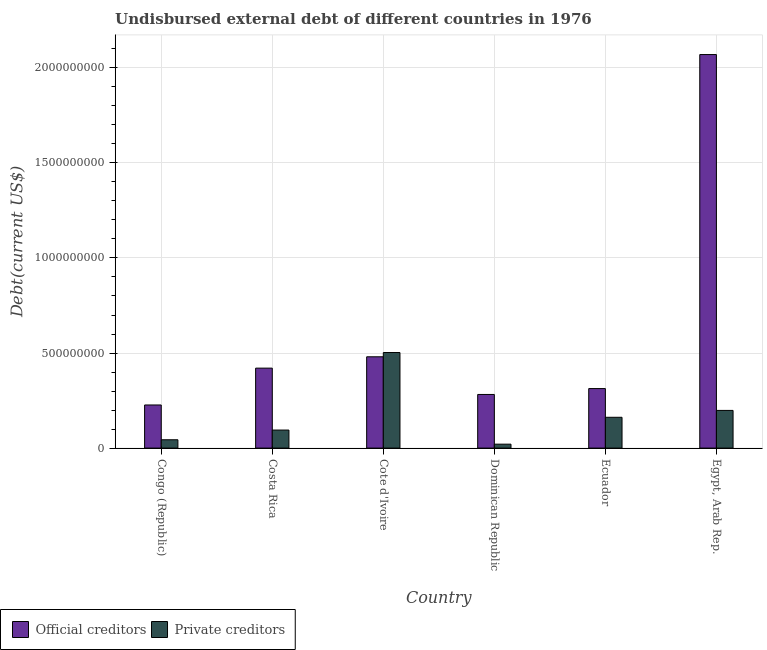How many groups of bars are there?
Your answer should be compact. 6. Are the number of bars per tick equal to the number of legend labels?
Make the answer very short. Yes. What is the label of the 2nd group of bars from the left?
Offer a terse response. Costa Rica. In how many cases, is the number of bars for a given country not equal to the number of legend labels?
Make the answer very short. 0. What is the undisbursed external debt of private creditors in Cote d'Ivoire?
Offer a very short reply. 5.03e+08. Across all countries, what is the maximum undisbursed external debt of private creditors?
Offer a terse response. 5.03e+08. Across all countries, what is the minimum undisbursed external debt of official creditors?
Make the answer very short. 2.27e+08. In which country was the undisbursed external debt of private creditors maximum?
Keep it short and to the point. Cote d'Ivoire. In which country was the undisbursed external debt of private creditors minimum?
Make the answer very short. Dominican Republic. What is the total undisbursed external debt of private creditors in the graph?
Ensure brevity in your answer.  1.02e+09. What is the difference between the undisbursed external debt of official creditors in Congo (Republic) and that in Costa Rica?
Ensure brevity in your answer.  -1.94e+08. What is the difference between the undisbursed external debt of private creditors in Cote d'Ivoire and the undisbursed external debt of official creditors in Dominican Republic?
Make the answer very short. 2.21e+08. What is the average undisbursed external debt of official creditors per country?
Your response must be concise. 6.32e+08. What is the difference between the undisbursed external debt of official creditors and undisbursed external debt of private creditors in Dominican Republic?
Your response must be concise. 2.61e+08. In how many countries, is the undisbursed external debt of official creditors greater than 1100000000 US$?
Give a very brief answer. 1. What is the ratio of the undisbursed external debt of private creditors in Congo (Republic) to that in Dominican Republic?
Keep it short and to the point. 2.12. Is the difference between the undisbursed external debt of private creditors in Ecuador and Egypt, Arab Rep. greater than the difference between the undisbursed external debt of official creditors in Ecuador and Egypt, Arab Rep.?
Ensure brevity in your answer.  Yes. What is the difference between the highest and the second highest undisbursed external debt of private creditors?
Offer a terse response. 3.04e+08. What is the difference between the highest and the lowest undisbursed external debt of private creditors?
Offer a very short reply. 4.82e+08. What does the 1st bar from the left in Cote d'Ivoire represents?
Provide a succinct answer. Official creditors. What does the 1st bar from the right in Costa Rica represents?
Your answer should be compact. Private creditors. How many bars are there?
Your answer should be compact. 12. Are all the bars in the graph horizontal?
Your answer should be compact. No. How many countries are there in the graph?
Your answer should be very brief. 6. What is the difference between two consecutive major ticks on the Y-axis?
Offer a terse response. 5.00e+08. Are the values on the major ticks of Y-axis written in scientific E-notation?
Your answer should be very brief. No. Where does the legend appear in the graph?
Provide a succinct answer. Bottom left. How many legend labels are there?
Keep it short and to the point. 2. How are the legend labels stacked?
Offer a terse response. Horizontal. What is the title of the graph?
Your answer should be very brief. Undisbursed external debt of different countries in 1976. Does "Foreign liabilities" appear as one of the legend labels in the graph?
Your answer should be very brief. No. What is the label or title of the X-axis?
Your answer should be very brief. Country. What is the label or title of the Y-axis?
Keep it short and to the point. Debt(current US$). What is the Debt(current US$) in Official creditors in Congo (Republic)?
Provide a succinct answer. 2.27e+08. What is the Debt(current US$) of Private creditors in Congo (Republic)?
Your answer should be compact. 4.38e+07. What is the Debt(current US$) in Official creditors in Costa Rica?
Make the answer very short. 4.21e+08. What is the Debt(current US$) of Private creditors in Costa Rica?
Your response must be concise. 9.49e+07. What is the Debt(current US$) of Official creditors in Cote d'Ivoire?
Provide a short and direct response. 4.80e+08. What is the Debt(current US$) in Private creditors in Cote d'Ivoire?
Your answer should be compact. 5.03e+08. What is the Debt(current US$) of Official creditors in Dominican Republic?
Offer a terse response. 2.82e+08. What is the Debt(current US$) of Private creditors in Dominican Republic?
Offer a very short reply. 2.07e+07. What is the Debt(current US$) of Official creditors in Ecuador?
Keep it short and to the point. 3.13e+08. What is the Debt(current US$) in Private creditors in Ecuador?
Your answer should be very brief. 1.62e+08. What is the Debt(current US$) in Official creditors in Egypt, Arab Rep.?
Keep it short and to the point. 2.07e+09. What is the Debt(current US$) in Private creditors in Egypt, Arab Rep.?
Make the answer very short. 1.98e+08. Across all countries, what is the maximum Debt(current US$) in Official creditors?
Make the answer very short. 2.07e+09. Across all countries, what is the maximum Debt(current US$) in Private creditors?
Your answer should be very brief. 5.03e+08. Across all countries, what is the minimum Debt(current US$) of Official creditors?
Offer a very short reply. 2.27e+08. Across all countries, what is the minimum Debt(current US$) in Private creditors?
Make the answer very short. 2.07e+07. What is the total Debt(current US$) of Official creditors in the graph?
Your response must be concise. 3.79e+09. What is the total Debt(current US$) in Private creditors in the graph?
Your response must be concise. 1.02e+09. What is the difference between the Debt(current US$) in Official creditors in Congo (Republic) and that in Costa Rica?
Offer a terse response. -1.94e+08. What is the difference between the Debt(current US$) of Private creditors in Congo (Republic) and that in Costa Rica?
Give a very brief answer. -5.11e+07. What is the difference between the Debt(current US$) in Official creditors in Congo (Republic) and that in Cote d'Ivoire?
Provide a succinct answer. -2.53e+08. What is the difference between the Debt(current US$) of Private creditors in Congo (Republic) and that in Cote d'Ivoire?
Your response must be concise. -4.59e+08. What is the difference between the Debt(current US$) in Official creditors in Congo (Republic) and that in Dominican Republic?
Your answer should be very brief. -5.53e+07. What is the difference between the Debt(current US$) of Private creditors in Congo (Republic) and that in Dominican Republic?
Provide a short and direct response. 2.31e+07. What is the difference between the Debt(current US$) in Official creditors in Congo (Republic) and that in Ecuador?
Make the answer very short. -8.63e+07. What is the difference between the Debt(current US$) of Private creditors in Congo (Republic) and that in Ecuador?
Your answer should be compact. -1.18e+08. What is the difference between the Debt(current US$) in Official creditors in Congo (Republic) and that in Egypt, Arab Rep.?
Provide a succinct answer. -1.84e+09. What is the difference between the Debt(current US$) in Private creditors in Congo (Republic) and that in Egypt, Arab Rep.?
Provide a succinct answer. -1.54e+08. What is the difference between the Debt(current US$) of Official creditors in Costa Rica and that in Cote d'Ivoire?
Offer a terse response. -5.97e+07. What is the difference between the Debt(current US$) in Private creditors in Costa Rica and that in Cote d'Ivoire?
Your response must be concise. -4.08e+08. What is the difference between the Debt(current US$) in Official creditors in Costa Rica and that in Dominican Republic?
Your answer should be very brief. 1.38e+08. What is the difference between the Debt(current US$) of Private creditors in Costa Rica and that in Dominican Republic?
Your response must be concise. 7.42e+07. What is the difference between the Debt(current US$) in Official creditors in Costa Rica and that in Ecuador?
Your answer should be compact. 1.07e+08. What is the difference between the Debt(current US$) of Private creditors in Costa Rica and that in Ecuador?
Your response must be concise. -6.72e+07. What is the difference between the Debt(current US$) in Official creditors in Costa Rica and that in Egypt, Arab Rep.?
Keep it short and to the point. -1.65e+09. What is the difference between the Debt(current US$) in Private creditors in Costa Rica and that in Egypt, Arab Rep.?
Offer a very short reply. -1.03e+08. What is the difference between the Debt(current US$) in Official creditors in Cote d'Ivoire and that in Dominican Republic?
Your answer should be very brief. 1.98e+08. What is the difference between the Debt(current US$) of Private creditors in Cote d'Ivoire and that in Dominican Republic?
Provide a succinct answer. 4.82e+08. What is the difference between the Debt(current US$) in Official creditors in Cote d'Ivoire and that in Ecuador?
Make the answer very short. 1.67e+08. What is the difference between the Debt(current US$) of Private creditors in Cote d'Ivoire and that in Ecuador?
Offer a very short reply. 3.41e+08. What is the difference between the Debt(current US$) of Official creditors in Cote d'Ivoire and that in Egypt, Arab Rep.?
Provide a succinct answer. -1.59e+09. What is the difference between the Debt(current US$) in Private creditors in Cote d'Ivoire and that in Egypt, Arab Rep.?
Offer a very short reply. 3.04e+08. What is the difference between the Debt(current US$) in Official creditors in Dominican Republic and that in Ecuador?
Your answer should be very brief. -3.10e+07. What is the difference between the Debt(current US$) of Private creditors in Dominican Republic and that in Ecuador?
Ensure brevity in your answer.  -1.41e+08. What is the difference between the Debt(current US$) in Official creditors in Dominican Republic and that in Egypt, Arab Rep.?
Offer a very short reply. -1.79e+09. What is the difference between the Debt(current US$) of Private creditors in Dominican Republic and that in Egypt, Arab Rep.?
Give a very brief answer. -1.78e+08. What is the difference between the Debt(current US$) in Official creditors in Ecuador and that in Egypt, Arab Rep.?
Offer a terse response. -1.76e+09. What is the difference between the Debt(current US$) of Private creditors in Ecuador and that in Egypt, Arab Rep.?
Keep it short and to the point. -3.62e+07. What is the difference between the Debt(current US$) of Official creditors in Congo (Republic) and the Debt(current US$) of Private creditors in Costa Rica?
Make the answer very short. 1.32e+08. What is the difference between the Debt(current US$) in Official creditors in Congo (Republic) and the Debt(current US$) in Private creditors in Cote d'Ivoire?
Your answer should be very brief. -2.76e+08. What is the difference between the Debt(current US$) in Official creditors in Congo (Republic) and the Debt(current US$) in Private creditors in Dominican Republic?
Provide a succinct answer. 2.06e+08. What is the difference between the Debt(current US$) in Official creditors in Congo (Republic) and the Debt(current US$) in Private creditors in Ecuador?
Your answer should be very brief. 6.48e+07. What is the difference between the Debt(current US$) in Official creditors in Congo (Republic) and the Debt(current US$) in Private creditors in Egypt, Arab Rep.?
Your answer should be compact. 2.86e+07. What is the difference between the Debt(current US$) in Official creditors in Costa Rica and the Debt(current US$) in Private creditors in Cote d'Ivoire?
Offer a terse response. -8.21e+07. What is the difference between the Debt(current US$) in Official creditors in Costa Rica and the Debt(current US$) in Private creditors in Dominican Republic?
Your response must be concise. 4.00e+08. What is the difference between the Debt(current US$) in Official creditors in Costa Rica and the Debt(current US$) in Private creditors in Ecuador?
Keep it short and to the point. 2.59e+08. What is the difference between the Debt(current US$) in Official creditors in Costa Rica and the Debt(current US$) in Private creditors in Egypt, Arab Rep.?
Make the answer very short. 2.22e+08. What is the difference between the Debt(current US$) of Official creditors in Cote d'Ivoire and the Debt(current US$) of Private creditors in Dominican Republic?
Ensure brevity in your answer.  4.60e+08. What is the difference between the Debt(current US$) of Official creditors in Cote d'Ivoire and the Debt(current US$) of Private creditors in Ecuador?
Give a very brief answer. 3.18e+08. What is the difference between the Debt(current US$) in Official creditors in Cote d'Ivoire and the Debt(current US$) in Private creditors in Egypt, Arab Rep.?
Offer a terse response. 2.82e+08. What is the difference between the Debt(current US$) of Official creditors in Dominican Republic and the Debt(current US$) of Private creditors in Ecuador?
Offer a terse response. 1.20e+08. What is the difference between the Debt(current US$) in Official creditors in Dominican Republic and the Debt(current US$) in Private creditors in Egypt, Arab Rep.?
Keep it short and to the point. 8.39e+07. What is the difference between the Debt(current US$) of Official creditors in Ecuador and the Debt(current US$) of Private creditors in Egypt, Arab Rep.?
Keep it short and to the point. 1.15e+08. What is the average Debt(current US$) in Official creditors per country?
Provide a short and direct response. 6.32e+08. What is the average Debt(current US$) in Private creditors per country?
Offer a very short reply. 1.70e+08. What is the difference between the Debt(current US$) of Official creditors and Debt(current US$) of Private creditors in Congo (Republic)?
Provide a short and direct response. 1.83e+08. What is the difference between the Debt(current US$) of Official creditors and Debt(current US$) of Private creditors in Costa Rica?
Offer a terse response. 3.26e+08. What is the difference between the Debt(current US$) of Official creditors and Debt(current US$) of Private creditors in Cote d'Ivoire?
Offer a very short reply. -2.24e+07. What is the difference between the Debt(current US$) of Official creditors and Debt(current US$) of Private creditors in Dominican Republic?
Your answer should be very brief. 2.61e+08. What is the difference between the Debt(current US$) of Official creditors and Debt(current US$) of Private creditors in Ecuador?
Ensure brevity in your answer.  1.51e+08. What is the difference between the Debt(current US$) of Official creditors and Debt(current US$) of Private creditors in Egypt, Arab Rep.?
Ensure brevity in your answer.  1.87e+09. What is the ratio of the Debt(current US$) in Official creditors in Congo (Republic) to that in Costa Rica?
Offer a very short reply. 0.54. What is the ratio of the Debt(current US$) of Private creditors in Congo (Republic) to that in Costa Rica?
Make the answer very short. 0.46. What is the ratio of the Debt(current US$) in Official creditors in Congo (Republic) to that in Cote d'Ivoire?
Offer a very short reply. 0.47. What is the ratio of the Debt(current US$) in Private creditors in Congo (Republic) to that in Cote d'Ivoire?
Provide a short and direct response. 0.09. What is the ratio of the Debt(current US$) in Official creditors in Congo (Republic) to that in Dominican Republic?
Offer a terse response. 0.8. What is the ratio of the Debt(current US$) of Private creditors in Congo (Republic) to that in Dominican Republic?
Give a very brief answer. 2.12. What is the ratio of the Debt(current US$) in Official creditors in Congo (Republic) to that in Ecuador?
Your answer should be very brief. 0.72. What is the ratio of the Debt(current US$) of Private creditors in Congo (Republic) to that in Ecuador?
Your answer should be very brief. 0.27. What is the ratio of the Debt(current US$) in Official creditors in Congo (Republic) to that in Egypt, Arab Rep.?
Keep it short and to the point. 0.11. What is the ratio of the Debt(current US$) of Private creditors in Congo (Republic) to that in Egypt, Arab Rep.?
Keep it short and to the point. 0.22. What is the ratio of the Debt(current US$) in Official creditors in Costa Rica to that in Cote d'Ivoire?
Your answer should be compact. 0.88. What is the ratio of the Debt(current US$) in Private creditors in Costa Rica to that in Cote d'Ivoire?
Your response must be concise. 0.19. What is the ratio of the Debt(current US$) of Official creditors in Costa Rica to that in Dominican Republic?
Ensure brevity in your answer.  1.49. What is the ratio of the Debt(current US$) in Private creditors in Costa Rica to that in Dominican Republic?
Provide a succinct answer. 4.59. What is the ratio of the Debt(current US$) in Official creditors in Costa Rica to that in Ecuador?
Offer a terse response. 1.34. What is the ratio of the Debt(current US$) of Private creditors in Costa Rica to that in Ecuador?
Make the answer very short. 0.59. What is the ratio of the Debt(current US$) in Official creditors in Costa Rica to that in Egypt, Arab Rep.?
Offer a very short reply. 0.2. What is the ratio of the Debt(current US$) of Private creditors in Costa Rica to that in Egypt, Arab Rep.?
Provide a succinct answer. 0.48. What is the ratio of the Debt(current US$) of Official creditors in Cote d'Ivoire to that in Dominican Republic?
Offer a very short reply. 1.7. What is the ratio of the Debt(current US$) of Private creditors in Cote d'Ivoire to that in Dominican Republic?
Ensure brevity in your answer.  24.34. What is the ratio of the Debt(current US$) in Official creditors in Cote d'Ivoire to that in Ecuador?
Provide a short and direct response. 1.53. What is the ratio of the Debt(current US$) of Private creditors in Cote d'Ivoire to that in Ecuador?
Make the answer very short. 3.1. What is the ratio of the Debt(current US$) in Official creditors in Cote d'Ivoire to that in Egypt, Arab Rep.?
Your response must be concise. 0.23. What is the ratio of the Debt(current US$) of Private creditors in Cote d'Ivoire to that in Egypt, Arab Rep.?
Your answer should be compact. 2.54. What is the ratio of the Debt(current US$) of Official creditors in Dominican Republic to that in Ecuador?
Keep it short and to the point. 0.9. What is the ratio of the Debt(current US$) in Private creditors in Dominican Republic to that in Ecuador?
Offer a very short reply. 0.13. What is the ratio of the Debt(current US$) of Official creditors in Dominican Republic to that in Egypt, Arab Rep.?
Your answer should be very brief. 0.14. What is the ratio of the Debt(current US$) in Private creditors in Dominican Republic to that in Egypt, Arab Rep.?
Provide a short and direct response. 0.1. What is the ratio of the Debt(current US$) in Official creditors in Ecuador to that in Egypt, Arab Rep.?
Provide a succinct answer. 0.15. What is the ratio of the Debt(current US$) of Private creditors in Ecuador to that in Egypt, Arab Rep.?
Ensure brevity in your answer.  0.82. What is the difference between the highest and the second highest Debt(current US$) of Official creditors?
Ensure brevity in your answer.  1.59e+09. What is the difference between the highest and the second highest Debt(current US$) of Private creditors?
Ensure brevity in your answer.  3.04e+08. What is the difference between the highest and the lowest Debt(current US$) of Official creditors?
Give a very brief answer. 1.84e+09. What is the difference between the highest and the lowest Debt(current US$) in Private creditors?
Your answer should be compact. 4.82e+08. 